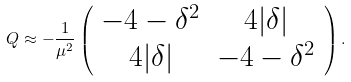Convert formula to latex. <formula><loc_0><loc_0><loc_500><loc_500>Q \approx - \frac { 1 } { \mu ^ { 2 } } \left ( \begin{array} { c c } - 4 - \delta ^ { 2 } & 4 | \delta | \\ 4 | \delta | & - 4 - \delta ^ { 2 } \end{array} \right ) .</formula> 